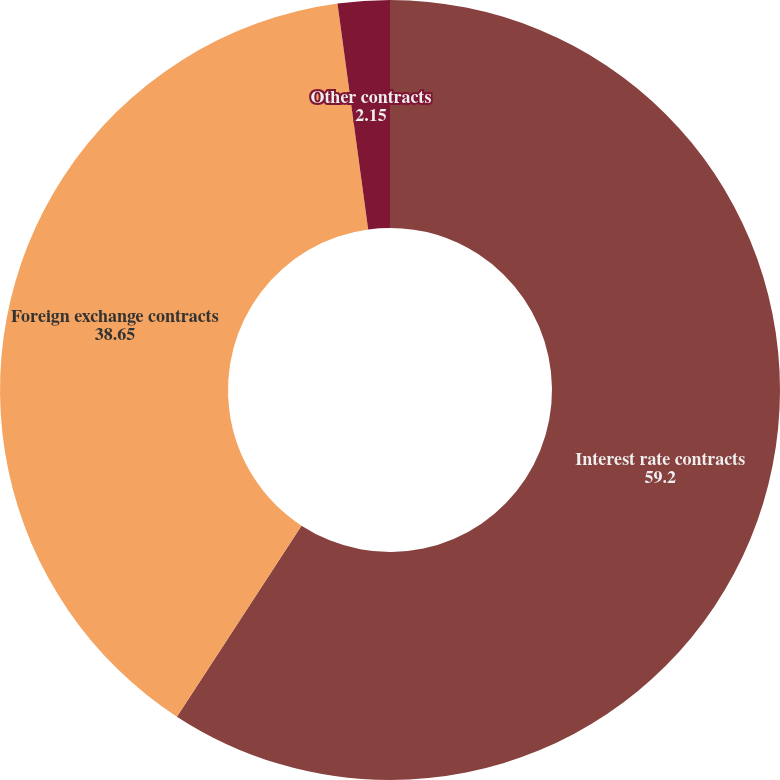<chart> <loc_0><loc_0><loc_500><loc_500><pie_chart><fcel>Interest rate contracts<fcel>Foreign exchange contracts<fcel>Other contracts<nl><fcel>59.2%<fcel>38.65%<fcel>2.15%<nl></chart> 